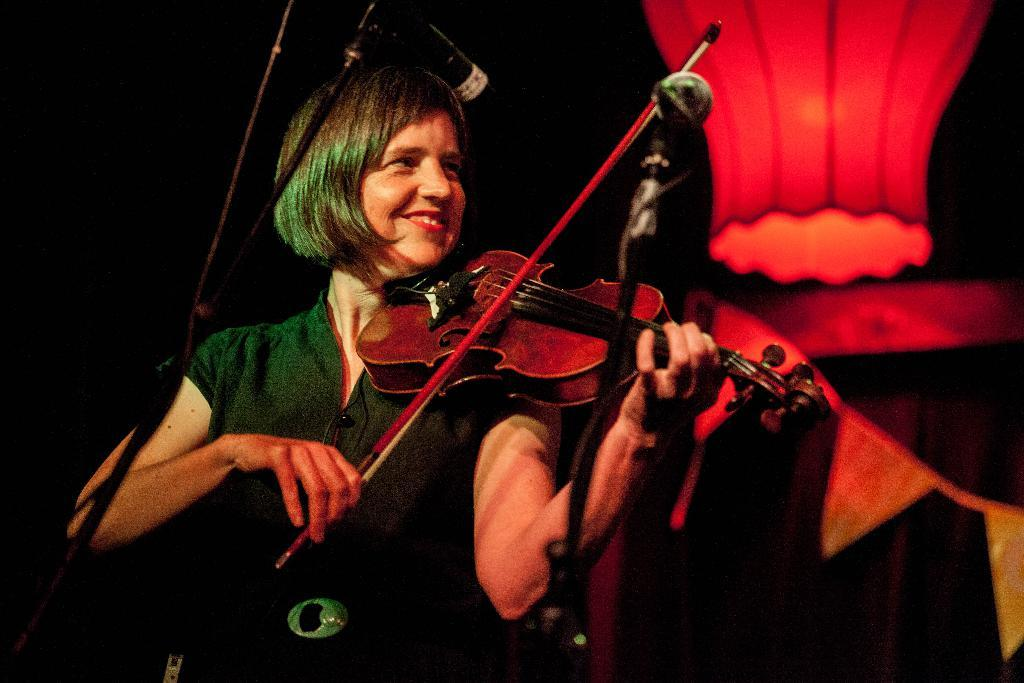Who is the main subject in the image? There is a woman in the image. What is the woman doing in the image? The woman is playing a violin. What can be seen near the woman in the image? There are two microphones in front of the woman. What color light is visible in the background of the image? There is a red color light in the background. What type of stew is being prepared in the image? There is no stew present in the image; it features a woman playing a violin with microphones and a red light in the background. What activity is the woman participating in at the park in the image? There is no park present in the image, and the woman is playing a violin, not participating in any park-related activity. 